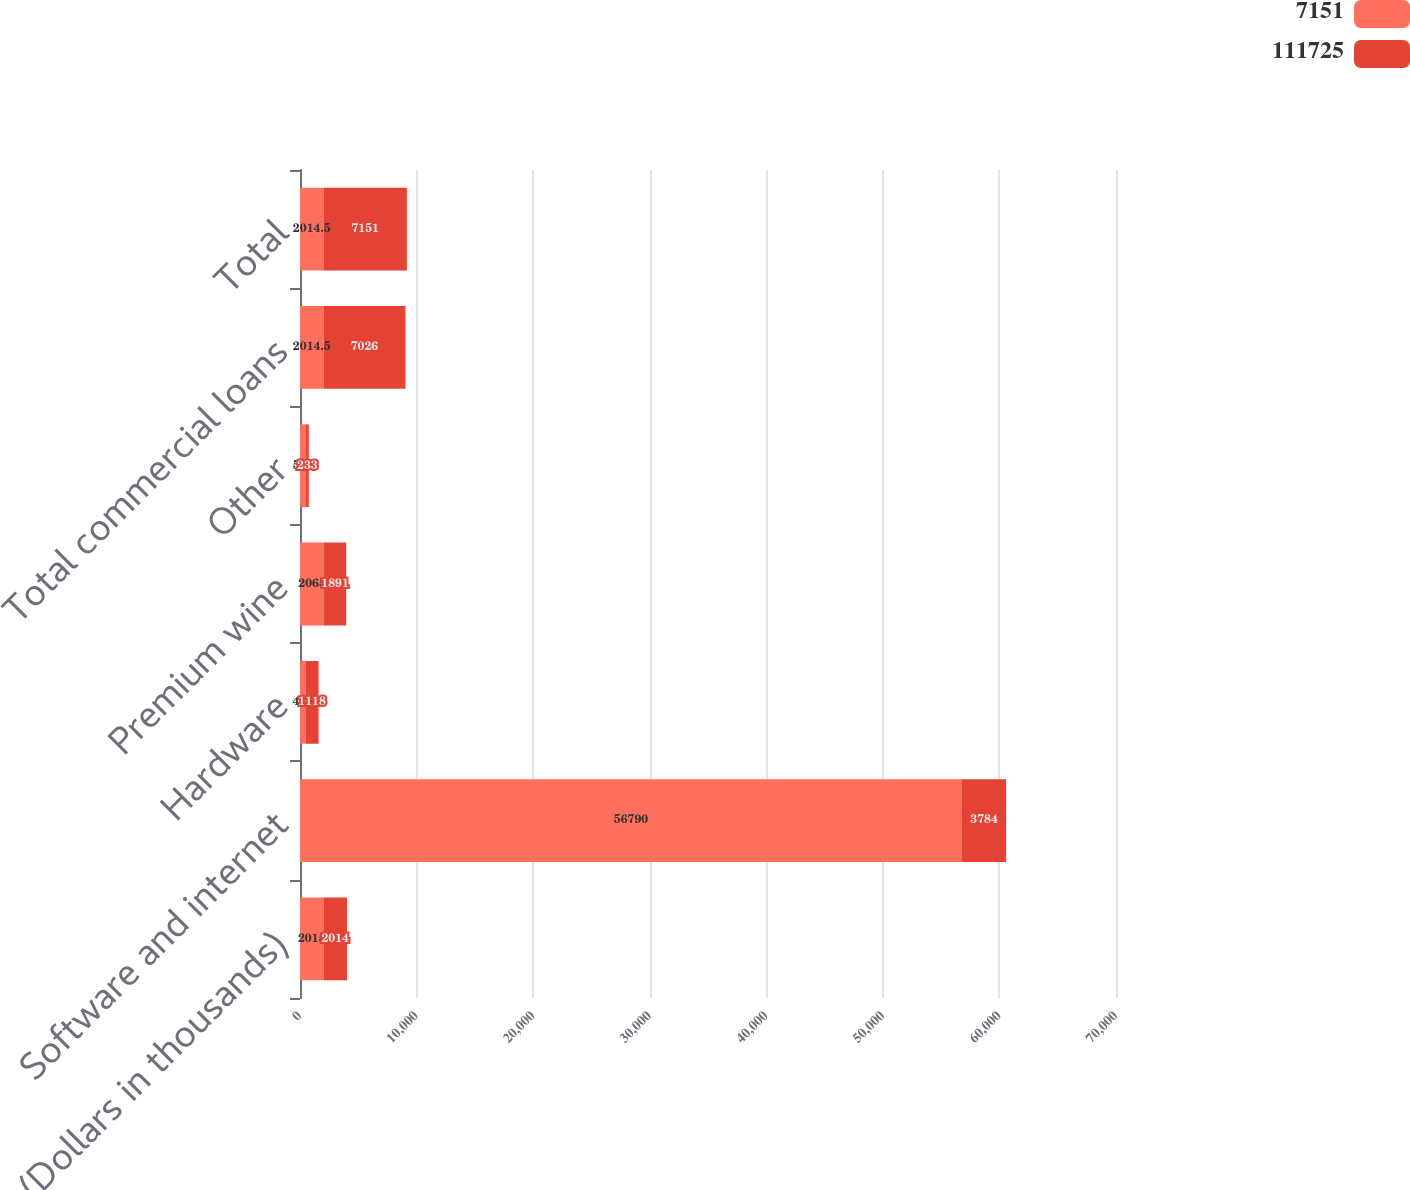<chart> <loc_0><loc_0><loc_500><loc_500><stacked_bar_chart><ecel><fcel>(Dollars in thousands)<fcel>Software and internet<fcel>Hardware<fcel>Premium wine<fcel>Other<fcel>Total commercial loans<fcel>Total<nl><fcel>7151<fcel>2015<fcel>56790<fcel>473<fcel>2065<fcel>519<fcel>2014.5<fcel>2014.5<nl><fcel>111725<fcel>2014<fcel>3784<fcel>1118<fcel>1891<fcel>233<fcel>7026<fcel>7151<nl></chart> 